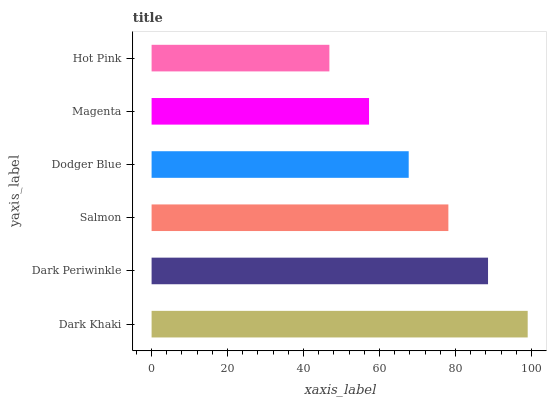Is Hot Pink the minimum?
Answer yes or no. Yes. Is Dark Khaki the maximum?
Answer yes or no. Yes. Is Dark Periwinkle the minimum?
Answer yes or no. No. Is Dark Periwinkle the maximum?
Answer yes or no. No. Is Dark Khaki greater than Dark Periwinkle?
Answer yes or no. Yes. Is Dark Periwinkle less than Dark Khaki?
Answer yes or no. Yes. Is Dark Periwinkle greater than Dark Khaki?
Answer yes or no. No. Is Dark Khaki less than Dark Periwinkle?
Answer yes or no. No. Is Salmon the high median?
Answer yes or no. Yes. Is Dodger Blue the low median?
Answer yes or no. Yes. Is Dodger Blue the high median?
Answer yes or no. No. Is Dark Periwinkle the low median?
Answer yes or no. No. 